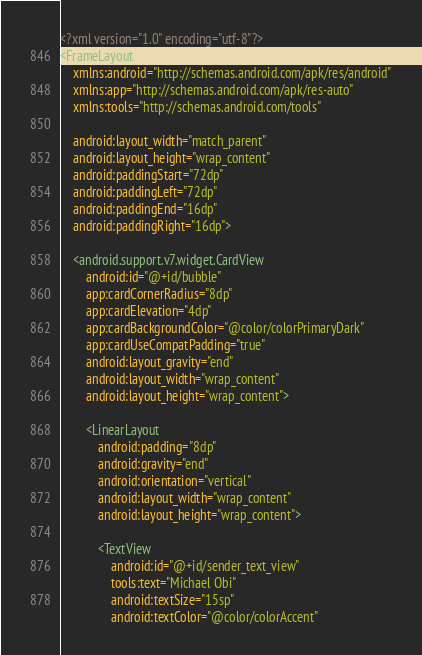Convert code to text. <code><loc_0><loc_0><loc_500><loc_500><_XML_><?xml version="1.0" encoding="utf-8"?>
<FrameLayout
    xmlns:android="http://schemas.android.com/apk/res/android"
    xmlns:app="http://schemas.android.com/apk/res-auto"
    xmlns:tools="http://schemas.android.com/tools"

    android:layout_width="match_parent"
    android:layout_height="wrap_content"
    android:paddingStart="72dp"
    android:paddingLeft="72dp"
    android:paddingEnd="16dp"
    android:paddingRight="16dp">

    <android.support.v7.widget.CardView
        android:id="@+id/bubble"
        app:cardCornerRadius="8dp"
        app:cardElevation="4dp"
        app:cardBackgroundColor="@color/colorPrimaryDark"
        app:cardUseCompatPadding="true"
        android:layout_gravity="end"
        android:layout_width="wrap_content"
        android:layout_height="wrap_content">

        <LinearLayout
            android:padding="8dp"
            android:gravity="end"
            android:orientation="vertical"
            android:layout_width="wrap_content"
            android:layout_height="wrap_content">

            <TextView
                android:id="@+id/sender_text_view"
                tools:text="Michael Obi"
                android:textSize="15sp"
                android:textColor="@color/colorAccent"</code> 